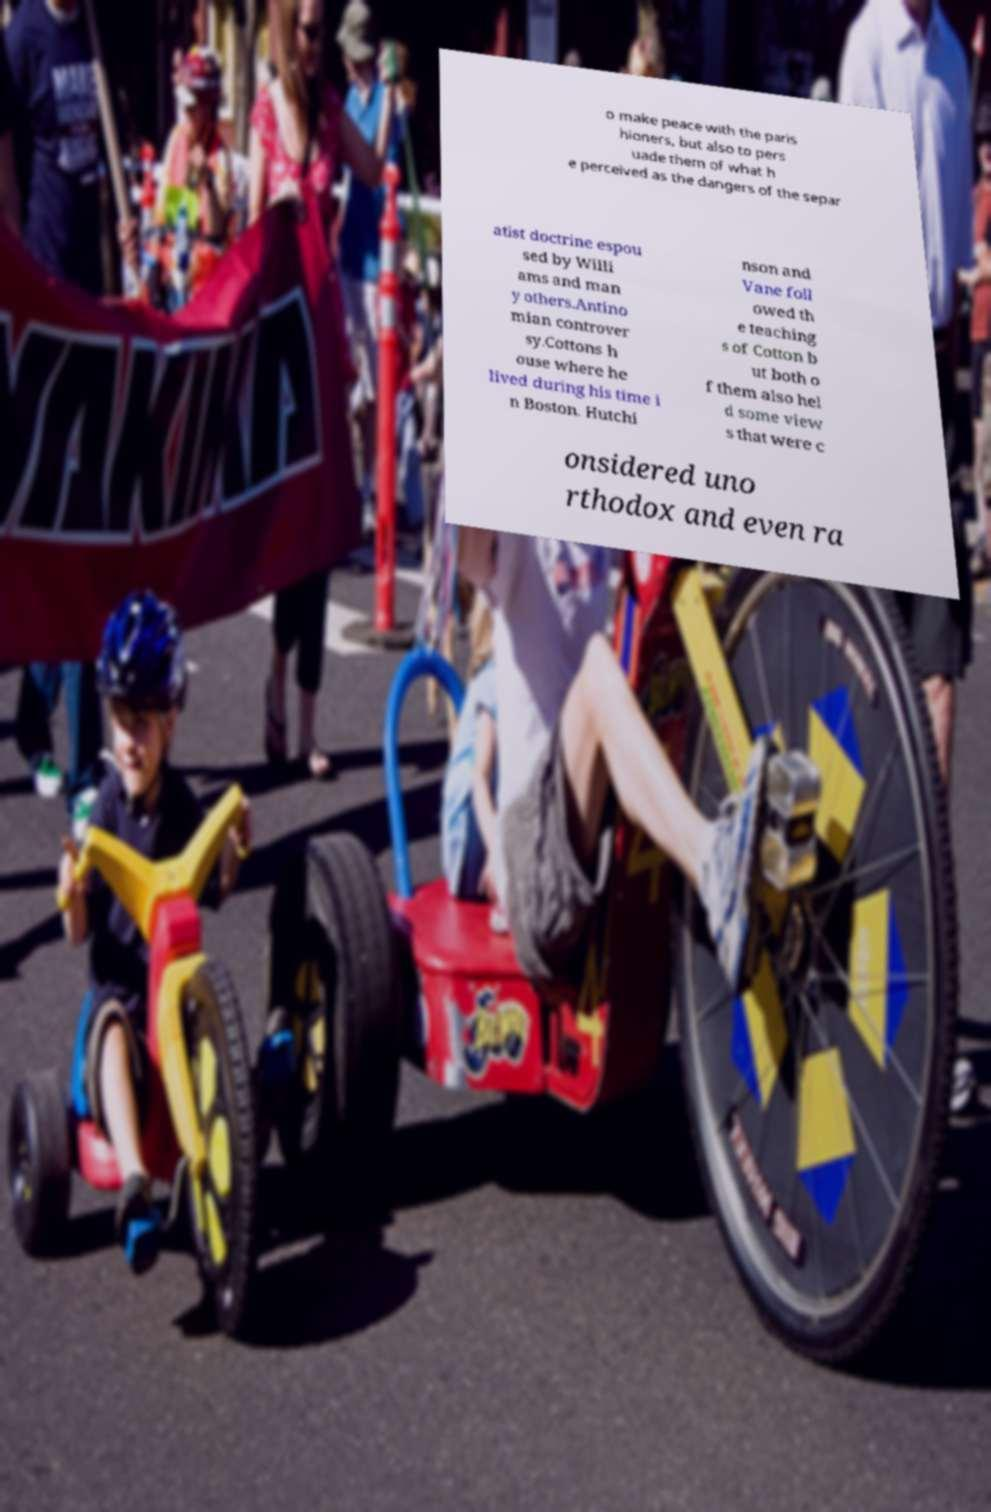Could you extract and type out the text from this image? o make peace with the paris hioners, but also to pers uade them of what h e perceived as the dangers of the separ atist doctrine espou sed by Willi ams and man y others.Antino mian controver sy.Cottons h ouse where he lived during his time i n Boston. Hutchi nson and Vane foll owed th e teaching s of Cotton b ut both o f them also hel d some view s that were c onsidered uno rthodox and even ra 